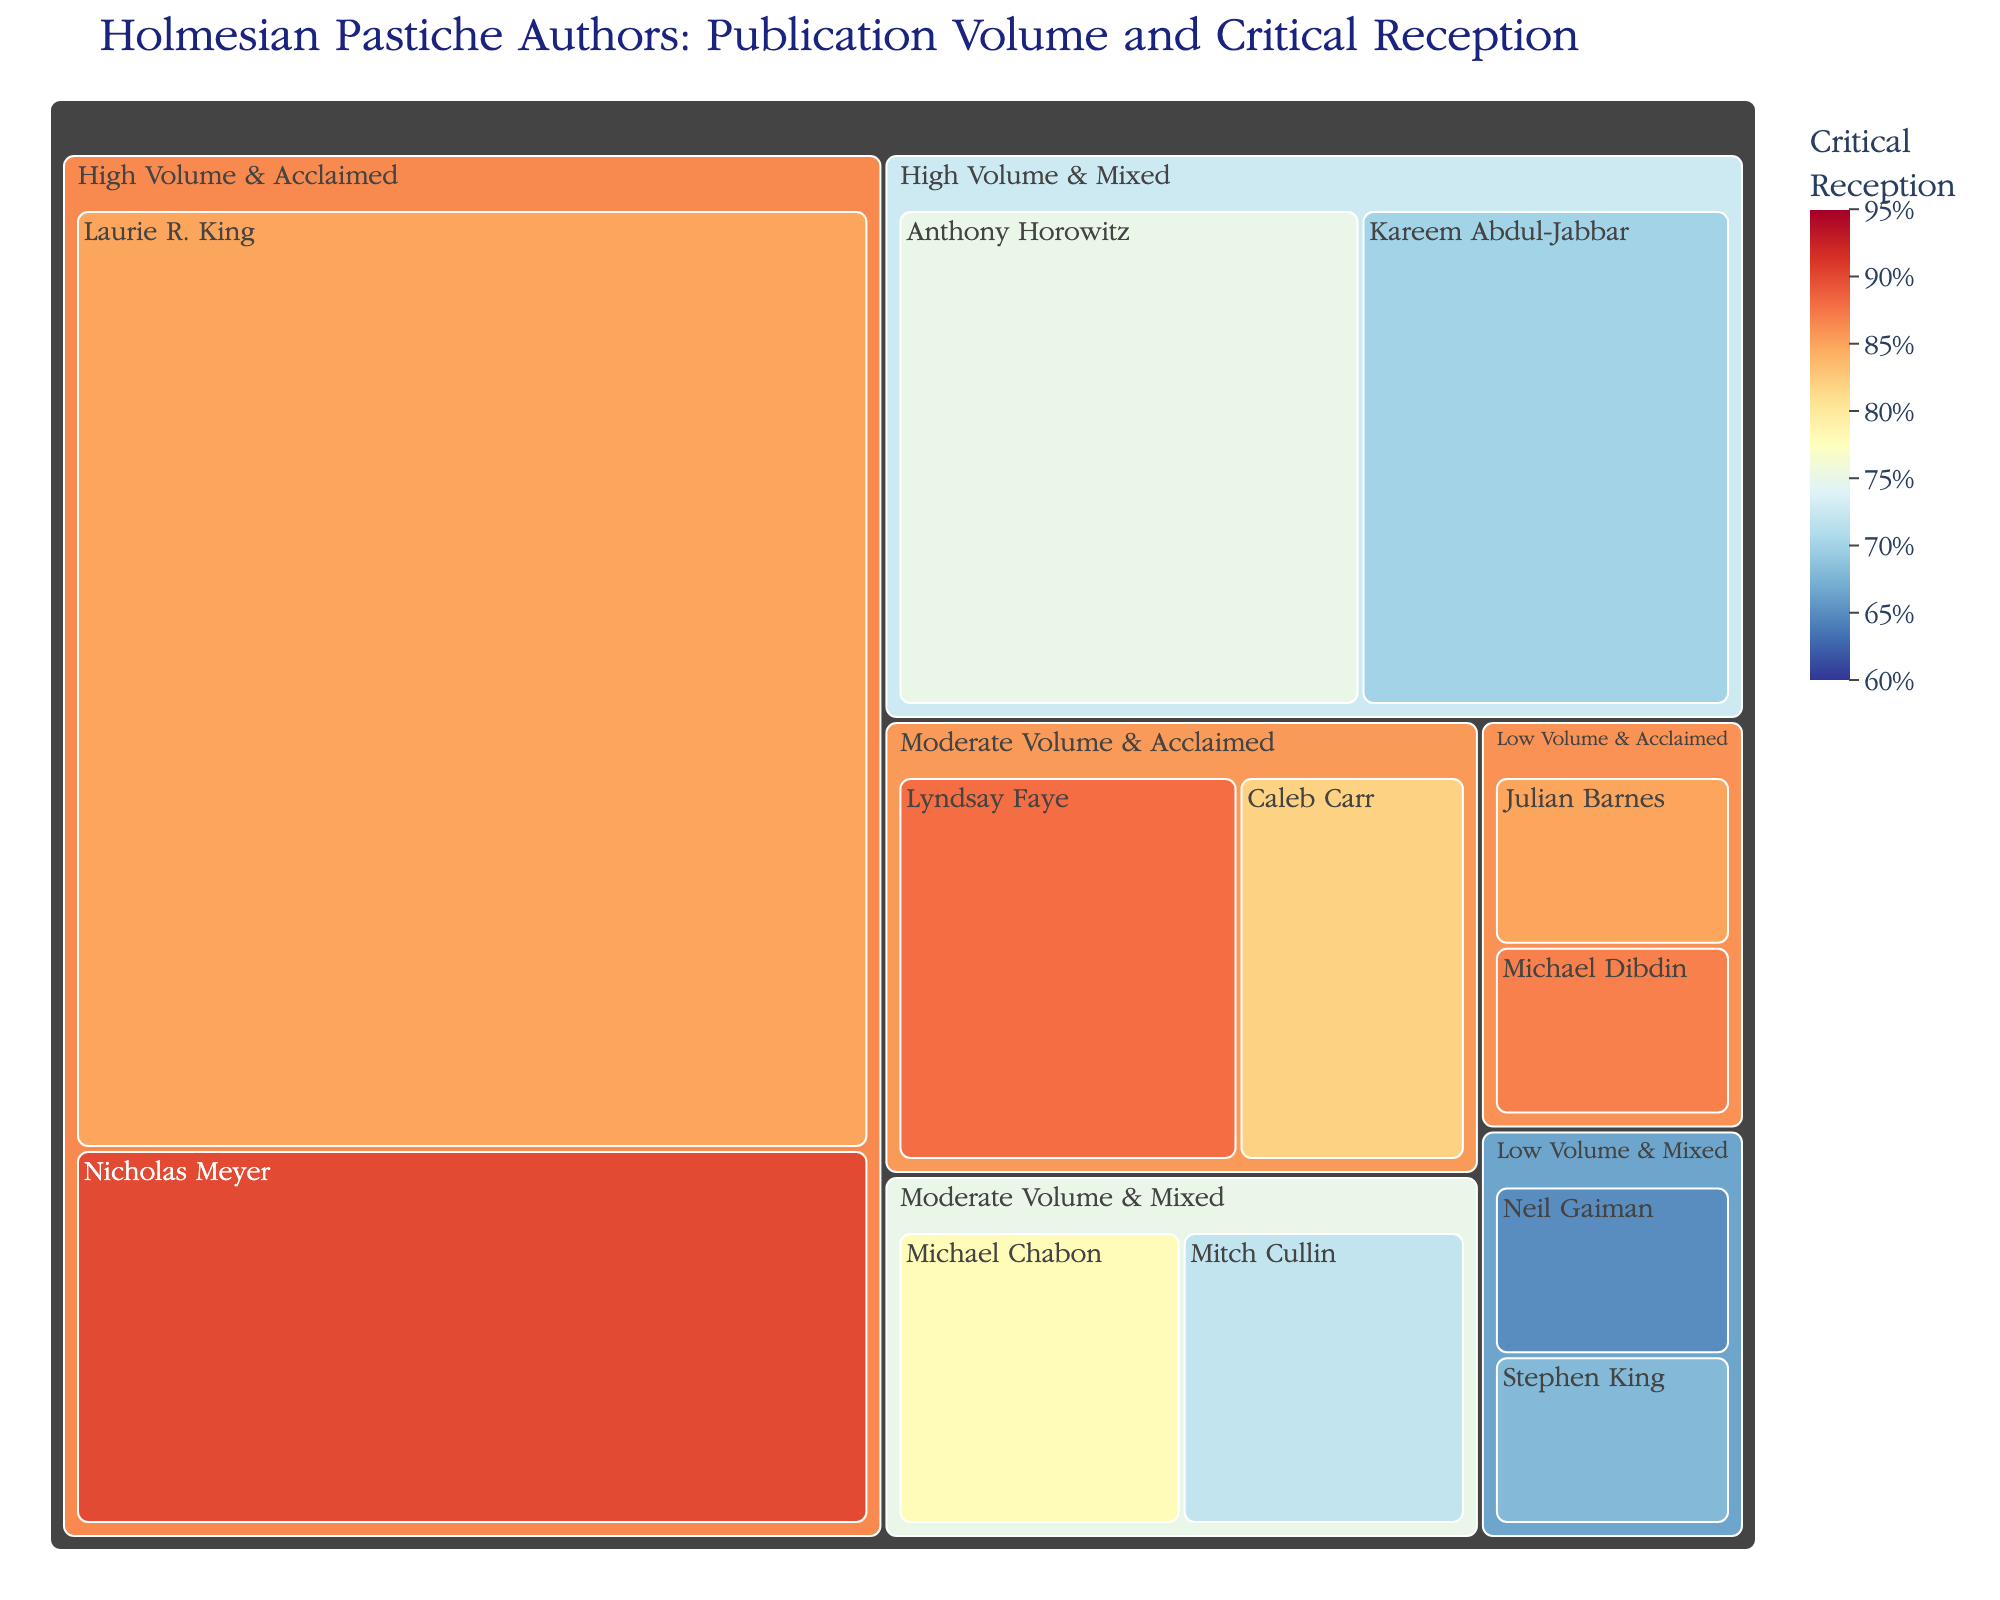What's the title of the treemap? The title of the treemap is displayed prominently at the top. It provides a summary of the data being visualized.
Answer: Holmesian Pastiche Authors: Publication Volume and Critical Reception Which author has the highest critical reception in the 'Moderate Volume & Acclaimed' category? First, locate the 'Moderate Volume & Acclaimed' category, then identify the author with the highest critical reception score within that category.
Answer: Lyndsay Faye How many authors are in the 'Low Volume & Mixed' category? Count the number of authors listed under the 'Low Volume & Mixed' category.
Answer: 2 What is the total number of publications by authors in the 'High Volume & Acclaimed' category? Identify the authors in the 'High Volume & Acclaimed' category, then sum up their publications: Laurie R. King (15) and Nicholas Meyer (6). The total is 15 + 6.
Answer: 21 Which category includes the author with the lowest critical reception, and who is the author? Look for the author with the lowest critical reception score across all categories, then determine which category they belong to. Neil Gaiman has the lowest critical reception score of 65. Check his category.
Answer: 'Low Volume & Mixed', Neil Gaiman Compare the critical reception of Michael Dibdin and Julian Barnes. Which one has a higher score? Find Michael Dibdin and Julian Barnes in the 'Low Volume & Acclaimed' category and compare their critical reception scores: Michael Dibdin (87) and Julian Barnes (85).
Answer: Michael Dibdin What are the tree segments (or tiles) color-coded by in the treemap? The color of each tile represents the "Critical Reception" percentage of the authors.
Answer: Critical Reception What is the difference in critical reception between Nicholas Meyer and Mitch Cullin? Identify the critical reception scores for Nicholas Meyer (90) and Mitch Cullin (72), then subtract Mitch Cullin's score from Nicholas Meyer's score: 90 - 72.
Answer: 18 How many authors have exactly one publication? Count the number of authors with a publication value of 1 from the data provided.
Answer: 4 What is the range of the color scale used in the treemap? The range of the color scale is mentioned in the details of the color scale settings, which ranges from the lowest to the highest value of critical reception displayed on the treemap.
Answer: 60 to 95 